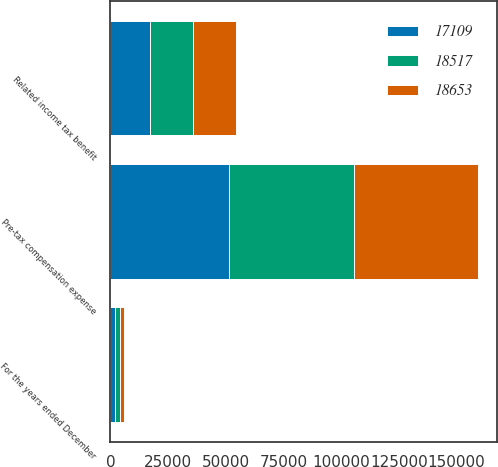Convert chart. <chart><loc_0><loc_0><loc_500><loc_500><stacked_bar_chart><ecel><fcel>For the years ended December<fcel>Pre-tax compensation expense<fcel>Related income tax benefit<nl><fcel>17109<fcel>2015<fcel>51533<fcel>17109<nl><fcel>18517<fcel>2014<fcel>54068<fcel>18653<nl><fcel>18653<fcel>2013<fcel>53984<fcel>18517<nl></chart> 